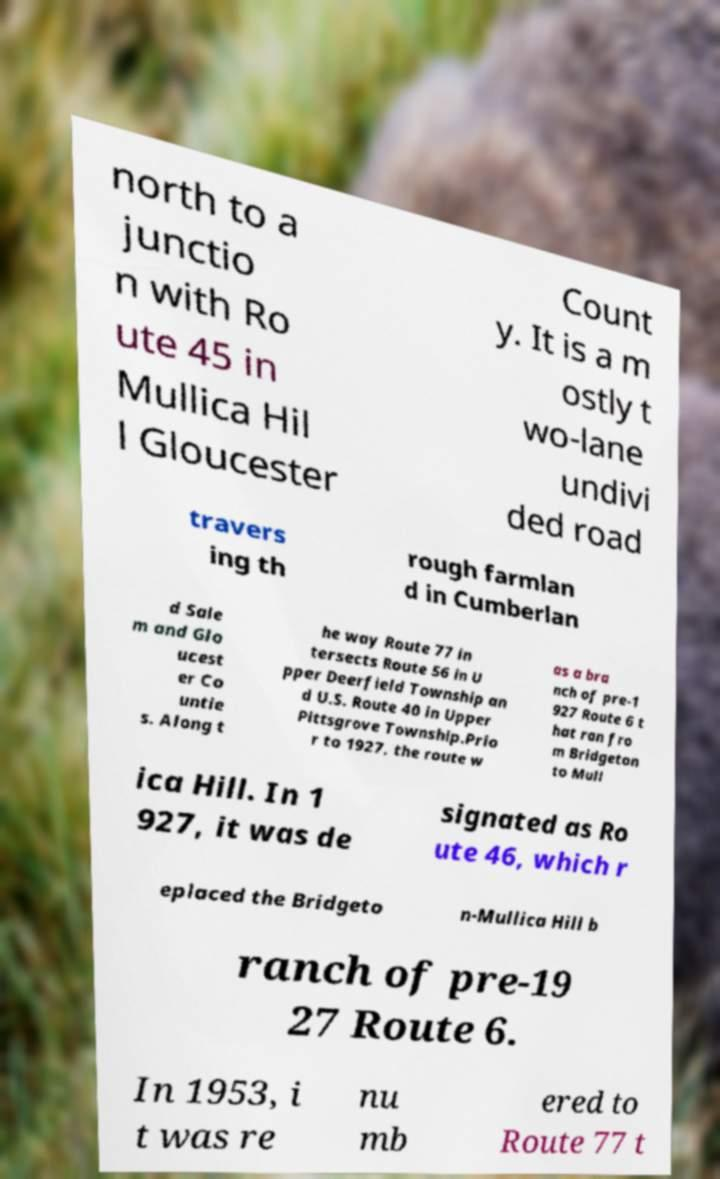For documentation purposes, I need the text within this image transcribed. Could you provide that? north to a junctio n with Ro ute 45 in Mullica Hil l Gloucester Count y. It is a m ostly t wo-lane undivi ded road travers ing th rough farmlan d in Cumberlan d Sale m and Glo ucest er Co untie s. Along t he way Route 77 in tersects Route 56 in U pper Deerfield Township an d U.S. Route 40 in Upper Pittsgrove Township.Prio r to 1927, the route w as a bra nch of pre-1 927 Route 6 t hat ran fro m Bridgeton to Mull ica Hill. In 1 927, it was de signated as Ro ute 46, which r eplaced the Bridgeto n-Mullica Hill b ranch of pre-19 27 Route 6. In 1953, i t was re nu mb ered to Route 77 t 